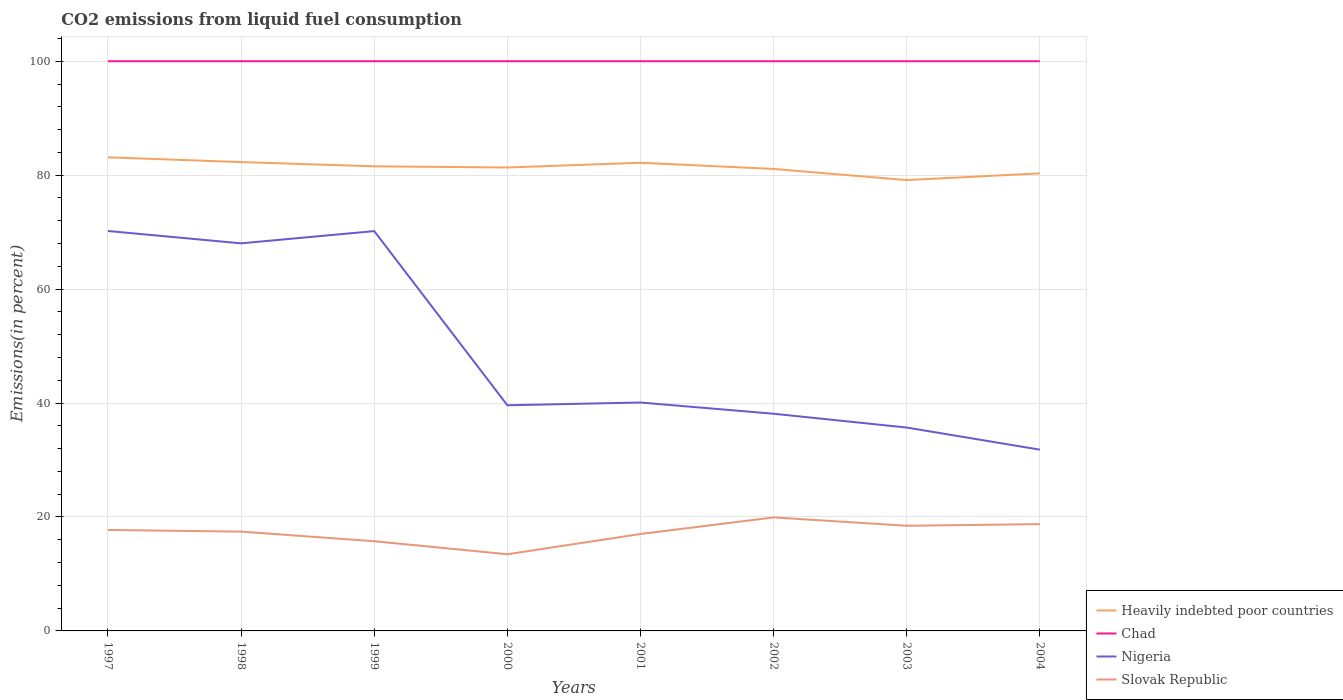How many different coloured lines are there?
Provide a short and direct response. 4. Across all years, what is the maximum total CO2 emitted in Nigeria?
Your answer should be very brief. 31.82. In which year was the total CO2 emitted in Nigeria maximum?
Ensure brevity in your answer.  2004. What is the total total CO2 emitted in Nigeria in the graph?
Make the answer very short. 7.79. What is the difference between the highest and the second highest total CO2 emitted in Heavily indebted poor countries?
Keep it short and to the point. 4. How many years are there in the graph?
Make the answer very short. 8. What is the difference between two consecutive major ticks on the Y-axis?
Provide a succinct answer. 20. Does the graph contain any zero values?
Make the answer very short. No. How many legend labels are there?
Provide a succinct answer. 4. What is the title of the graph?
Your response must be concise. CO2 emissions from liquid fuel consumption. Does "Cayman Islands" appear as one of the legend labels in the graph?
Your answer should be compact. No. What is the label or title of the X-axis?
Offer a very short reply. Years. What is the label or title of the Y-axis?
Ensure brevity in your answer.  Emissions(in percent). What is the Emissions(in percent) of Heavily indebted poor countries in 1997?
Make the answer very short. 83.13. What is the Emissions(in percent) in Nigeria in 1997?
Your answer should be very brief. 70.2. What is the Emissions(in percent) in Slovak Republic in 1997?
Ensure brevity in your answer.  17.72. What is the Emissions(in percent) of Heavily indebted poor countries in 1998?
Your answer should be very brief. 82.3. What is the Emissions(in percent) of Chad in 1998?
Provide a short and direct response. 100. What is the Emissions(in percent) in Nigeria in 1998?
Make the answer very short. 68.03. What is the Emissions(in percent) of Slovak Republic in 1998?
Provide a short and direct response. 17.43. What is the Emissions(in percent) of Heavily indebted poor countries in 1999?
Offer a terse response. 81.55. What is the Emissions(in percent) in Nigeria in 1999?
Provide a succinct answer. 70.18. What is the Emissions(in percent) in Slovak Republic in 1999?
Ensure brevity in your answer.  15.75. What is the Emissions(in percent) in Heavily indebted poor countries in 2000?
Your response must be concise. 81.35. What is the Emissions(in percent) of Nigeria in 2000?
Offer a very short reply. 39.61. What is the Emissions(in percent) of Slovak Republic in 2000?
Your answer should be compact. 13.46. What is the Emissions(in percent) of Heavily indebted poor countries in 2001?
Provide a succinct answer. 82.18. What is the Emissions(in percent) of Nigeria in 2001?
Your response must be concise. 40.09. What is the Emissions(in percent) in Slovak Republic in 2001?
Offer a terse response. 17.01. What is the Emissions(in percent) of Heavily indebted poor countries in 2002?
Keep it short and to the point. 81.09. What is the Emissions(in percent) in Chad in 2002?
Offer a very short reply. 100. What is the Emissions(in percent) in Nigeria in 2002?
Keep it short and to the point. 38.12. What is the Emissions(in percent) of Slovak Republic in 2002?
Offer a terse response. 19.93. What is the Emissions(in percent) of Heavily indebted poor countries in 2003?
Provide a short and direct response. 79.14. What is the Emissions(in percent) in Chad in 2003?
Your answer should be very brief. 100. What is the Emissions(in percent) of Nigeria in 2003?
Keep it short and to the point. 35.7. What is the Emissions(in percent) of Slovak Republic in 2003?
Give a very brief answer. 18.46. What is the Emissions(in percent) of Heavily indebted poor countries in 2004?
Keep it short and to the point. 80.32. What is the Emissions(in percent) of Nigeria in 2004?
Your answer should be compact. 31.82. What is the Emissions(in percent) of Slovak Republic in 2004?
Your answer should be very brief. 18.75. Across all years, what is the maximum Emissions(in percent) in Heavily indebted poor countries?
Your response must be concise. 83.13. Across all years, what is the maximum Emissions(in percent) in Chad?
Keep it short and to the point. 100. Across all years, what is the maximum Emissions(in percent) in Nigeria?
Provide a succinct answer. 70.2. Across all years, what is the maximum Emissions(in percent) of Slovak Republic?
Your response must be concise. 19.93. Across all years, what is the minimum Emissions(in percent) in Heavily indebted poor countries?
Give a very brief answer. 79.14. Across all years, what is the minimum Emissions(in percent) of Nigeria?
Your answer should be compact. 31.82. Across all years, what is the minimum Emissions(in percent) of Slovak Republic?
Offer a terse response. 13.46. What is the total Emissions(in percent) of Heavily indebted poor countries in the graph?
Ensure brevity in your answer.  651.05. What is the total Emissions(in percent) in Chad in the graph?
Provide a short and direct response. 800. What is the total Emissions(in percent) in Nigeria in the graph?
Give a very brief answer. 393.75. What is the total Emissions(in percent) in Slovak Republic in the graph?
Your answer should be very brief. 138.5. What is the difference between the Emissions(in percent) in Heavily indebted poor countries in 1997 and that in 1998?
Your answer should be very brief. 0.84. What is the difference between the Emissions(in percent) of Nigeria in 1997 and that in 1998?
Offer a very short reply. 2.17. What is the difference between the Emissions(in percent) of Slovak Republic in 1997 and that in 1998?
Provide a short and direct response. 0.29. What is the difference between the Emissions(in percent) of Heavily indebted poor countries in 1997 and that in 1999?
Offer a terse response. 1.58. What is the difference between the Emissions(in percent) in Chad in 1997 and that in 1999?
Provide a succinct answer. 0. What is the difference between the Emissions(in percent) of Nigeria in 1997 and that in 1999?
Provide a short and direct response. 0.02. What is the difference between the Emissions(in percent) in Slovak Republic in 1997 and that in 1999?
Provide a short and direct response. 1.98. What is the difference between the Emissions(in percent) in Heavily indebted poor countries in 1997 and that in 2000?
Provide a short and direct response. 1.79. What is the difference between the Emissions(in percent) of Nigeria in 1997 and that in 2000?
Make the answer very short. 30.59. What is the difference between the Emissions(in percent) of Slovak Republic in 1997 and that in 2000?
Make the answer very short. 4.27. What is the difference between the Emissions(in percent) in Heavily indebted poor countries in 1997 and that in 2001?
Provide a succinct answer. 0.96. What is the difference between the Emissions(in percent) of Chad in 1997 and that in 2001?
Offer a very short reply. 0. What is the difference between the Emissions(in percent) of Nigeria in 1997 and that in 2001?
Offer a very short reply. 30.11. What is the difference between the Emissions(in percent) in Slovak Republic in 1997 and that in 2001?
Your answer should be very brief. 0.71. What is the difference between the Emissions(in percent) in Heavily indebted poor countries in 1997 and that in 2002?
Provide a succinct answer. 2.04. What is the difference between the Emissions(in percent) in Chad in 1997 and that in 2002?
Ensure brevity in your answer.  0. What is the difference between the Emissions(in percent) in Nigeria in 1997 and that in 2002?
Give a very brief answer. 32.08. What is the difference between the Emissions(in percent) in Slovak Republic in 1997 and that in 2002?
Your response must be concise. -2.2. What is the difference between the Emissions(in percent) of Heavily indebted poor countries in 1997 and that in 2003?
Provide a succinct answer. 4. What is the difference between the Emissions(in percent) in Chad in 1997 and that in 2003?
Your answer should be compact. 0. What is the difference between the Emissions(in percent) in Nigeria in 1997 and that in 2003?
Your answer should be very brief. 34.5. What is the difference between the Emissions(in percent) of Slovak Republic in 1997 and that in 2003?
Offer a very short reply. -0.73. What is the difference between the Emissions(in percent) in Heavily indebted poor countries in 1997 and that in 2004?
Offer a very short reply. 2.82. What is the difference between the Emissions(in percent) of Nigeria in 1997 and that in 2004?
Your answer should be very brief. 38.39. What is the difference between the Emissions(in percent) of Slovak Republic in 1997 and that in 2004?
Ensure brevity in your answer.  -1.02. What is the difference between the Emissions(in percent) of Heavily indebted poor countries in 1998 and that in 1999?
Give a very brief answer. 0.74. What is the difference between the Emissions(in percent) in Chad in 1998 and that in 1999?
Make the answer very short. 0. What is the difference between the Emissions(in percent) of Nigeria in 1998 and that in 1999?
Your response must be concise. -2.15. What is the difference between the Emissions(in percent) of Slovak Republic in 1998 and that in 1999?
Your answer should be very brief. 1.68. What is the difference between the Emissions(in percent) of Heavily indebted poor countries in 1998 and that in 2000?
Your answer should be compact. 0.95. What is the difference between the Emissions(in percent) in Nigeria in 1998 and that in 2000?
Provide a short and direct response. 28.42. What is the difference between the Emissions(in percent) of Slovak Republic in 1998 and that in 2000?
Give a very brief answer. 3.97. What is the difference between the Emissions(in percent) of Heavily indebted poor countries in 1998 and that in 2001?
Ensure brevity in your answer.  0.12. What is the difference between the Emissions(in percent) of Nigeria in 1998 and that in 2001?
Your response must be concise. 27.94. What is the difference between the Emissions(in percent) in Slovak Republic in 1998 and that in 2001?
Provide a succinct answer. 0.42. What is the difference between the Emissions(in percent) in Heavily indebted poor countries in 1998 and that in 2002?
Provide a succinct answer. 1.2. What is the difference between the Emissions(in percent) in Nigeria in 1998 and that in 2002?
Your response must be concise. 29.91. What is the difference between the Emissions(in percent) of Slovak Republic in 1998 and that in 2002?
Ensure brevity in your answer.  -2.5. What is the difference between the Emissions(in percent) in Heavily indebted poor countries in 1998 and that in 2003?
Keep it short and to the point. 3.16. What is the difference between the Emissions(in percent) in Chad in 1998 and that in 2003?
Offer a terse response. 0. What is the difference between the Emissions(in percent) in Nigeria in 1998 and that in 2003?
Keep it short and to the point. 32.33. What is the difference between the Emissions(in percent) in Slovak Republic in 1998 and that in 2003?
Provide a succinct answer. -1.03. What is the difference between the Emissions(in percent) of Heavily indebted poor countries in 1998 and that in 2004?
Your answer should be compact. 1.98. What is the difference between the Emissions(in percent) in Chad in 1998 and that in 2004?
Offer a terse response. 0. What is the difference between the Emissions(in percent) of Nigeria in 1998 and that in 2004?
Your answer should be compact. 36.22. What is the difference between the Emissions(in percent) of Slovak Republic in 1998 and that in 2004?
Your answer should be very brief. -1.32. What is the difference between the Emissions(in percent) in Heavily indebted poor countries in 1999 and that in 2000?
Keep it short and to the point. 0.21. What is the difference between the Emissions(in percent) of Chad in 1999 and that in 2000?
Provide a succinct answer. 0. What is the difference between the Emissions(in percent) of Nigeria in 1999 and that in 2000?
Offer a terse response. 30.57. What is the difference between the Emissions(in percent) in Slovak Republic in 1999 and that in 2000?
Your answer should be compact. 2.29. What is the difference between the Emissions(in percent) of Heavily indebted poor countries in 1999 and that in 2001?
Your answer should be compact. -0.62. What is the difference between the Emissions(in percent) of Nigeria in 1999 and that in 2001?
Make the answer very short. 30.09. What is the difference between the Emissions(in percent) in Slovak Republic in 1999 and that in 2001?
Offer a very short reply. -1.27. What is the difference between the Emissions(in percent) of Heavily indebted poor countries in 1999 and that in 2002?
Ensure brevity in your answer.  0.46. What is the difference between the Emissions(in percent) in Nigeria in 1999 and that in 2002?
Provide a short and direct response. 32.06. What is the difference between the Emissions(in percent) of Slovak Republic in 1999 and that in 2002?
Keep it short and to the point. -4.18. What is the difference between the Emissions(in percent) in Heavily indebted poor countries in 1999 and that in 2003?
Your response must be concise. 2.42. What is the difference between the Emissions(in percent) in Nigeria in 1999 and that in 2003?
Offer a terse response. 34.48. What is the difference between the Emissions(in percent) of Slovak Republic in 1999 and that in 2003?
Ensure brevity in your answer.  -2.71. What is the difference between the Emissions(in percent) in Heavily indebted poor countries in 1999 and that in 2004?
Provide a succinct answer. 1.24. What is the difference between the Emissions(in percent) of Chad in 1999 and that in 2004?
Offer a terse response. 0. What is the difference between the Emissions(in percent) in Nigeria in 1999 and that in 2004?
Offer a very short reply. 38.37. What is the difference between the Emissions(in percent) of Slovak Republic in 1999 and that in 2004?
Offer a very short reply. -3. What is the difference between the Emissions(in percent) in Heavily indebted poor countries in 2000 and that in 2001?
Ensure brevity in your answer.  -0.83. What is the difference between the Emissions(in percent) in Nigeria in 2000 and that in 2001?
Offer a terse response. -0.48. What is the difference between the Emissions(in percent) in Slovak Republic in 2000 and that in 2001?
Keep it short and to the point. -3.55. What is the difference between the Emissions(in percent) of Heavily indebted poor countries in 2000 and that in 2002?
Your answer should be compact. 0.25. What is the difference between the Emissions(in percent) in Nigeria in 2000 and that in 2002?
Provide a short and direct response. 1.49. What is the difference between the Emissions(in percent) in Slovak Republic in 2000 and that in 2002?
Your response must be concise. -6.47. What is the difference between the Emissions(in percent) of Heavily indebted poor countries in 2000 and that in 2003?
Offer a terse response. 2.21. What is the difference between the Emissions(in percent) in Chad in 2000 and that in 2003?
Provide a short and direct response. 0. What is the difference between the Emissions(in percent) in Nigeria in 2000 and that in 2003?
Provide a succinct answer. 3.91. What is the difference between the Emissions(in percent) in Slovak Republic in 2000 and that in 2003?
Your answer should be compact. -5. What is the difference between the Emissions(in percent) in Heavily indebted poor countries in 2000 and that in 2004?
Ensure brevity in your answer.  1.03. What is the difference between the Emissions(in percent) in Chad in 2000 and that in 2004?
Give a very brief answer. 0. What is the difference between the Emissions(in percent) of Nigeria in 2000 and that in 2004?
Your answer should be compact. 7.79. What is the difference between the Emissions(in percent) in Slovak Republic in 2000 and that in 2004?
Make the answer very short. -5.29. What is the difference between the Emissions(in percent) in Heavily indebted poor countries in 2001 and that in 2002?
Ensure brevity in your answer.  1.08. What is the difference between the Emissions(in percent) of Chad in 2001 and that in 2002?
Your answer should be compact. 0. What is the difference between the Emissions(in percent) of Nigeria in 2001 and that in 2002?
Keep it short and to the point. 1.97. What is the difference between the Emissions(in percent) of Slovak Republic in 2001 and that in 2002?
Your response must be concise. -2.91. What is the difference between the Emissions(in percent) of Heavily indebted poor countries in 2001 and that in 2003?
Give a very brief answer. 3.04. What is the difference between the Emissions(in percent) of Nigeria in 2001 and that in 2003?
Provide a succinct answer. 4.39. What is the difference between the Emissions(in percent) in Slovak Republic in 2001 and that in 2003?
Offer a very short reply. -1.45. What is the difference between the Emissions(in percent) in Heavily indebted poor countries in 2001 and that in 2004?
Your answer should be very brief. 1.86. What is the difference between the Emissions(in percent) in Chad in 2001 and that in 2004?
Your response must be concise. 0. What is the difference between the Emissions(in percent) in Nigeria in 2001 and that in 2004?
Your answer should be very brief. 8.28. What is the difference between the Emissions(in percent) in Slovak Republic in 2001 and that in 2004?
Your answer should be compact. -1.73. What is the difference between the Emissions(in percent) in Heavily indebted poor countries in 2002 and that in 2003?
Make the answer very short. 1.96. What is the difference between the Emissions(in percent) in Nigeria in 2002 and that in 2003?
Give a very brief answer. 2.42. What is the difference between the Emissions(in percent) in Slovak Republic in 2002 and that in 2003?
Your response must be concise. 1.47. What is the difference between the Emissions(in percent) of Heavily indebted poor countries in 2002 and that in 2004?
Provide a succinct answer. 0.78. What is the difference between the Emissions(in percent) in Chad in 2002 and that in 2004?
Offer a very short reply. 0. What is the difference between the Emissions(in percent) in Nigeria in 2002 and that in 2004?
Your answer should be compact. 6.31. What is the difference between the Emissions(in percent) in Slovak Republic in 2002 and that in 2004?
Give a very brief answer. 1.18. What is the difference between the Emissions(in percent) of Heavily indebted poor countries in 2003 and that in 2004?
Give a very brief answer. -1.18. What is the difference between the Emissions(in percent) in Nigeria in 2003 and that in 2004?
Provide a short and direct response. 3.88. What is the difference between the Emissions(in percent) of Slovak Republic in 2003 and that in 2004?
Your answer should be compact. -0.29. What is the difference between the Emissions(in percent) of Heavily indebted poor countries in 1997 and the Emissions(in percent) of Chad in 1998?
Your response must be concise. -16.87. What is the difference between the Emissions(in percent) in Heavily indebted poor countries in 1997 and the Emissions(in percent) in Nigeria in 1998?
Your answer should be very brief. 15.1. What is the difference between the Emissions(in percent) of Heavily indebted poor countries in 1997 and the Emissions(in percent) of Slovak Republic in 1998?
Ensure brevity in your answer.  65.7. What is the difference between the Emissions(in percent) of Chad in 1997 and the Emissions(in percent) of Nigeria in 1998?
Your answer should be very brief. 31.97. What is the difference between the Emissions(in percent) in Chad in 1997 and the Emissions(in percent) in Slovak Republic in 1998?
Ensure brevity in your answer.  82.57. What is the difference between the Emissions(in percent) in Nigeria in 1997 and the Emissions(in percent) in Slovak Republic in 1998?
Offer a very short reply. 52.77. What is the difference between the Emissions(in percent) in Heavily indebted poor countries in 1997 and the Emissions(in percent) in Chad in 1999?
Offer a very short reply. -16.87. What is the difference between the Emissions(in percent) in Heavily indebted poor countries in 1997 and the Emissions(in percent) in Nigeria in 1999?
Provide a succinct answer. 12.95. What is the difference between the Emissions(in percent) in Heavily indebted poor countries in 1997 and the Emissions(in percent) in Slovak Republic in 1999?
Offer a very short reply. 67.39. What is the difference between the Emissions(in percent) in Chad in 1997 and the Emissions(in percent) in Nigeria in 1999?
Your answer should be very brief. 29.82. What is the difference between the Emissions(in percent) in Chad in 1997 and the Emissions(in percent) in Slovak Republic in 1999?
Your answer should be compact. 84.25. What is the difference between the Emissions(in percent) of Nigeria in 1997 and the Emissions(in percent) of Slovak Republic in 1999?
Provide a succinct answer. 54.45. What is the difference between the Emissions(in percent) in Heavily indebted poor countries in 1997 and the Emissions(in percent) in Chad in 2000?
Your answer should be compact. -16.87. What is the difference between the Emissions(in percent) of Heavily indebted poor countries in 1997 and the Emissions(in percent) of Nigeria in 2000?
Make the answer very short. 43.52. What is the difference between the Emissions(in percent) of Heavily indebted poor countries in 1997 and the Emissions(in percent) of Slovak Republic in 2000?
Your answer should be compact. 69.67. What is the difference between the Emissions(in percent) of Chad in 1997 and the Emissions(in percent) of Nigeria in 2000?
Provide a short and direct response. 60.39. What is the difference between the Emissions(in percent) in Chad in 1997 and the Emissions(in percent) in Slovak Republic in 2000?
Offer a very short reply. 86.54. What is the difference between the Emissions(in percent) of Nigeria in 1997 and the Emissions(in percent) of Slovak Republic in 2000?
Offer a terse response. 56.74. What is the difference between the Emissions(in percent) of Heavily indebted poor countries in 1997 and the Emissions(in percent) of Chad in 2001?
Provide a short and direct response. -16.87. What is the difference between the Emissions(in percent) in Heavily indebted poor countries in 1997 and the Emissions(in percent) in Nigeria in 2001?
Offer a very short reply. 43.04. What is the difference between the Emissions(in percent) of Heavily indebted poor countries in 1997 and the Emissions(in percent) of Slovak Republic in 2001?
Your response must be concise. 66.12. What is the difference between the Emissions(in percent) in Chad in 1997 and the Emissions(in percent) in Nigeria in 2001?
Provide a succinct answer. 59.91. What is the difference between the Emissions(in percent) of Chad in 1997 and the Emissions(in percent) of Slovak Republic in 2001?
Your response must be concise. 82.99. What is the difference between the Emissions(in percent) in Nigeria in 1997 and the Emissions(in percent) in Slovak Republic in 2001?
Offer a very short reply. 53.19. What is the difference between the Emissions(in percent) of Heavily indebted poor countries in 1997 and the Emissions(in percent) of Chad in 2002?
Give a very brief answer. -16.87. What is the difference between the Emissions(in percent) of Heavily indebted poor countries in 1997 and the Emissions(in percent) of Nigeria in 2002?
Ensure brevity in your answer.  45.01. What is the difference between the Emissions(in percent) of Heavily indebted poor countries in 1997 and the Emissions(in percent) of Slovak Republic in 2002?
Give a very brief answer. 63.21. What is the difference between the Emissions(in percent) in Chad in 1997 and the Emissions(in percent) in Nigeria in 2002?
Your response must be concise. 61.88. What is the difference between the Emissions(in percent) in Chad in 1997 and the Emissions(in percent) in Slovak Republic in 2002?
Ensure brevity in your answer.  80.07. What is the difference between the Emissions(in percent) in Nigeria in 1997 and the Emissions(in percent) in Slovak Republic in 2002?
Your answer should be compact. 50.27. What is the difference between the Emissions(in percent) in Heavily indebted poor countries in 1997 and the Emissions(in percent) in Chad in 2003?
Ensure brevity in your answer.  -16.87. What is the difference between the Emissions(in percent) of Heavily indebted poor countries in 1997 and the Emissions(in percent) of Nigeria in 2003?
Offer a terse response. 47.43. What is the difference between the Emissions(in percent) of Heavily indebted poor countries in 1997 and the Emissions(in percent) of Slovak Republic in 2003?
Your answer should be very brief. 64.67. What is the difference between the Emissions(in percent) in Chad in 1997 and the Emissions(in percent) in Nigeria in 2003?
Keep it short and to the point. 64.3. What is the difference between the Emissions(in percent) of Chad in 1997 and the Emissions(in percent) of Slovak Republic in 2003?
Make the answer very short. 81.54. What is the difference between the Emissions(in percent) in Nigeria in 1997 and the Emissions(in percent) in Slovak Republic in 2003?
Give a very brief answer. 51.74. What is the difference between the Emissions(in percent) in Heavily indebted poor countries in 1997 and the Emissions(in percent) in Chad in 2004?
Offer a terse response. -16.87. What is the difference between the Emissions(in percent) of Heavily indebted poor countries in 1997 and the Emissions(in percent) of Nigeria in 2004?
Give a very brief answer. 51.32. What is the difference between the Emissions(in percent) of Heavily indebted poor countries in 1997 and the Emissions(in percent) of Slovak Republic in 2004?
Your answer should be very brief. 64.39. What is the difference between the Emissions(in percent) in Chad in 1997 and the Emissions(in percent) in Nigeria in 2004?
Offer a very short reply. 68.18. What is the difference between the Emissions(in percent) in Chad in 1997 and the Emissions(in percent) in Slovak Republic in 2004?
Ensure brevity in your answer.  81.25. What is the difference between the Emissions(in percent) of Nigeria in 1997 and the Emissions(in percent) of Slovak Republic in 2004?
Give a very brief answer. 51.45. What is the difference between the Emissions(in percent) in Heavily indebted poor countries in 1998 and the Emissions(in percent) in Chad in 1999?
Offer a terse response. -17.7. What is the difference between the Emissions(in percent) of Heavily indebted poor countries in 1998 and the Emissions(in percent) of Nigeria in 1999?
Offer a very short reply. 12.11. What is the difference between the Emissions(in percent) of Heavily indebted poor countries in 1998 and the Emissions(in percent) of Slovak Republic in 1999?
Offer a very short reply. 66.55. What is the difference between the Emissions(in percent) of Chad in 1998 and the Emissions(in percent) of Nigeria in 1999?
Make the answer very short. 29.82. What is the difference between the Emissions(in percent) in Chad in 1998 and the Emissions(in percent) in Slovak Republic in 1999?
Your response must be concise. 84.25. What is the difference between the Emissions(in percent) of Nigeria in 1998 and the Emissions(in percent) of Slovak Republic in 1999?
Give a very brief answer. 52.29. What is the difference between the Emissions(in percent) of Heavily indebted poor countries in 1998 and the Emissions(in percent) of Chad in 2000?
Provide a succinct answer. -17.7. What is the difference between the Emissions(in percent) of Heavily indebted poor countries in 1998 and the Emissions(in percent) of Nigeria in 2000?
Keep it short and to the point. 42.69. What is the difference between the Emissions(in percent) of Heavily indebted poor countries in 1998 and the Emissions(in percent) of Slovak Republic in 2000?
Provide a succinct answer. 68.84. What is the difference between the Emissions(in percent) of Chad in 1998 and the Emissions(in percent) of Nigeria in 2000?
Ensure brevity in your answer.  60.39. What is the difference between the Emissions(in percent) in Chad in 1998 and the Emissions(in percent) in Slovak Republic in 2000?
Make the answer very short. 86.54. What is the difference between the Emissions(in percent) of Nigeria in 1998 and the Emissions(in percent) of Slovak Republic in 2000?
Provide a succinct answer. 54.57. What is the difference between the Emissions(in percent) of Heavily indebted poor countries in 1998 and the Emissions(in percent) of Chad in 2001?
Offer a terse response. -17.7. What is the difference between the Emissions(in percent) in Heavily indebted poor countries in 1998 and the Emissions(in percent) in Nigeria in 2001?
Provide a succinct answer. 42.2. What is the difference between the Emissions(in percent) of Heavily indebted poor countries in 1998 and the Emissions(in percent) of Slovak Republic in 2001?
Your answer should be compact. 65.28. What is the difference between the Emissions(in percent) in Chad in 1998 and the Emissions(in percent) in Nigeria in 2001?
Your answer should be very brief. 59.91. What is the difference between the Emissions(in percent) of Chad in 1998 and the Emissions(in percent) of Slovak Republic in 2001?
Provide a short and direct response. 82.99. What is the difference between the Emissions(in percent) of Nigeria in 1998 and the Emissions(in percent) of Slovak Republic in 2001?
Provide a short and direct response. 51.02. What is the difference between the Emissions(in percent) in Heavily indebted poor countries in 1998 and the Emissions(in percent) in Chad in 2002?
Offer a very short reply. -17.7. What is the difference between the Emissions(in percent) of Heavily indebted poor countries in 1998 and the Emissions(in percent) of Nigeria in 2002?
Your answer should be very brief. 44.17. What is the difference between the Emissions(in percent) in Heavily indebted poor countries in 1998 and the Emissions(in percent) in Slovak Republic in 2002?
Keep it short and to the point. 62.37. What is the difference between the Emissions(in percent) in Chad in 1998 and the Emissions(in percent) in Nigeria in 2002?
Offer a terse response. 61.88. What is the difference between the Emissions(in percent) in Chad in 1998 and the Emissions(in percent) in Slovak Republic in 2002?
Give a very brief answer. 80.07. What is the difference between the Emissions(in percent) in Nigeria in 1998 and the Emissions(in percent) in Slovak Republic in 2002?
Provide a succinct answer. 48.11. What is the difference between the Emissions(in percent) in Heavily indebted poor countries in 1998 and the Emissions(in percent) in Chad in 2003?
Keep it short and to the point. -17.7. What is the difference between the Emissions(in percent) of Heavily indebted poor countries in 1998 and the Emissions(in percent) of Nigeria in 2003?
Offer a terse response. 46.6. What is the difference between the Emissions(in percent) in Heavily indebted poor countries in 1998 and the Emissions(in percent) in Slovak Republic in 2003?
Ensure brevity in your answer.  63.84. What is the difference between the Emissions(in percent) in Chad in 1998 and the Emissions(in percent) in Nigeria in 2003?
Make the answer very short. 64.3. What is the difference between the Emissions(in percent) of Chad in 1998 and the Emissions(in percent) of Slovak Republic in 2003?
Your response must be concise. 81.54. What is the difference between the Emissions(in percent) of Nigeria in 1998 and the Emissions(in percent) of Slovak Republic in 2003?
Provide a succinct answer. 49.57. What is the difference between the Emissions(in percent) of Heavily indebted poor countries in 1998 and the Emissions(in percent) of Chad in 2004?
Keep it short and to the point. -17.7. What is the difference between the Emissions(in percent) in Heavily indebted poor countries in 1998 and the Emissions(in percent) in Nigeria in 2004?
Your answer should be very brief. 50.48. What is the difference between the Emissions(in percent) of Heavily indebted poor countries in 1998 and the Emissions(in percent) of Slovak Republic in 2004?
Your response must be concise. 63.55. What is the difference between the Emissions(in percent) in Chad in 1998 and the Emissions(in percent) in Nigeria in 2004?
Your response must be concise. 68.18. What is the difference between the Emissions(in percent) of Chad in 1998 and the Emissions(in percent) of Slovak Republic in 2004?
Make the answer very short. 81.25. What is the difference between the Emissions(in percent) of Nigeria in 1998 and the Emissions(in percent) of Slovak Republic in 2004?
Provide a succinct answer. 49.29. What is the difference between the Emissions(in percent) of Heavily indebted poor countries in 1999 and the Emissions(in percent) of Chad in 2000?
Offer a terse response. -18.45. What is the difference between the Emissions(in percent) of Heavily indebted poor countries in 1999 and the Emissions(in percent) of Nigeria in 2000?
Keep it short and to the point. 41.94. What is the difference between the Emissions(in percent) in Heavily indebted poor countries in 1999 and the Emissions(in percent) in Slovak Republic in 2000?
Make the answer very short. 68.1. What is the difference between the Emissions(in percent) in Chad in 1999 and the Emissions(in percent) in Nigeria in 2000?
Provide a short and direct response. 60.39. What is the difference between the Emissions(in percent) of Chad in 1999 and the Emissions(in percent) of Slovak Republic in 2000?
Ensure brevity in your answer.  86.54. What is the difference between the Emissions(in percent) in Nigeria in 1999 and the Emissions(in percent) in Slovak Republic in 2000?
Ensure brevity in your answer.  56.72. What is the difference between the Emissions(in percent) of Heavily indebted poor countries in 1999 and the Emissions(in percent) of Chad in 2001?
Keep it short and to the point. -18.45. What is the difference between the Emissions(in percent) of Heavily indebted poor countries in 1999 and the Emissions(in percent) of Nigeria in 2001?
Your answer should be compact. 41.46. What is the difference between the Emissions(in percent) of Heavily indebted poor countries in 1999 and the Emissions(in percent) of Slovak Republic in 2001?
Provide a short and direct response. 64.54. What is the difference between the Emissions(in percent) in Chad in 1999 and the Emissions(in percent) in Nigeria in 2001?
Provide a succinct answer. 59.91. What is the difference between the Emissions(in percent) in Chad in 1999 and the Emissions(in percent) in Slovak Republic in 2001?
Your response must be concise. 82.99. What is the difference between the Emissions(in percent) in Nigeria in 1999 and the Emissions(in percent) in Slovak Republic in 2001?
Give a very brief answer. 53.17. What is the difference between the Emissions(in percent) in Heavily indebted poor countries in 1999 and the Emissions(in percent) in Chad in 2002?
Offer a terse response. -18.45. What is the difference between the Emissions(in percent) of Heavily indebted poor countries in 1999 and the Emissions(in percent) of Nigeria in 2002?
Your response must be concise. 43.43. What is the difference between the Emissions(in percent) in Heavily indebted poor countries in 1999 and the Emissions(in percent) in Slovak Republic in 2002?
Your response must be concise. 61.63. What is the difference between the Emissions(in percent) of Chad in 1999 and the Emissions(in percent) of Nigeria in 2002?
Give a very brief answer. 61.88. What is the difference between the Emissions(in percent) of Chad in 1999 and the Emissions(in percent) of Slovak Republic in 2002?
Your response must be concise. 80.07. What is the difference between the Emissions(in percent) in Nigeria in 1999 and the Emissions(in percent) in Slovak Republic in 2002?
Make the answer very short. 50.25. What is the difference between the Emissions(in percent) in Heavily indebted poor countries in 1999 and the Emissions(in percent) in Chad in 2003?
Offer a very short reply. -18.45. What is the difference between the Emissions(in percent) of Heavily indebted poor countries in 1999 and the Emissions(in percent) of Nigeria in 2003?
Your response must be concise. 45.86. What is the difference between the Emissions(in percent) in Heavily indebted poor countries in 1999 and the Emissions(in percent) in Slovak Republic in 2003?
Ensure brevity in your answer.  63.1. What is the difference between the Emissions(in percent) of Chad in 1999 and the Emissions(in percent) of Nigeria in 2003?
Ensure brevity in your answer.  64.3. What is the difference between the Emissions(in percent) of Chad in 1999 and the Emissions(in percent) of Slovak Republic in 2003?
Ensure brevity in your answer.  81.54. What is the difference between the Emissions(in percent) in Nigeria in 1999 and the Emissions(in percent) in Slovak Republic in 2003?
Offer a very short reply. 51.72. What is the difference between the Emissions(in percent) of Heavily indebted poor countries in 1999 and the Emissions(in percent) of Chad in 2004?
Make the answer very short. -18.45. What is the difference between the Emissions(in percent) of Heavily indebted poor countries in 1999 and the Emissions(in percent) of Nigeria in 2004?
Your response must be concise. 49.74. What is the difference between the Emissions(in percent) of Heavily indebted poor countries in 1999 and the Emissions(in percent) of Slovak Republic in 2004?
Keep it short and to the point. 62.81. What is the difference between the Emissions(in percent) in Chad in 1999 and the Emissions(in percent) in Nigeria in 2004?
Provide a short and direct response. 68.18. What is the difference between the Emissions(in percent) in Chad in 1999 and the Emissions(in percent) in Slovak Republic in 2004?
Keep it short and to the point. 81.25. What is the difference between the Emissions(in percent) of Nigeria in 1999 and the Emissions(in percent) of Slovak Republic in 2004?
Provide a short and direct response. 51.43. What is the difference between the Emissions(in percent) of Heavily indebted poor countries in 2000 and the Emissions(in percent) of Chad in 2001?
Your answer should be very brief. -18.65. What is the difference between the Emissions(in percent) in Heavily indebted poor countries in 2000 and the Emissions(in percent) in Nigeria in 2001?
Make the answer very short. 41.25. What is the difference between the Emissions(in percent) of Heavily indebted poor countries in 2000 and the Emissions(in percent) of Slovak Republic in 2001?
Give a very brief answer. 64.33. What is the difference between the Emissions(in percent) in Chad in 2000 and the Emissions(in percent) in Nigeria in 2001?
Offer a terse response. 59.91. What is the difference between the Emissions(in percent) of Chad in 2000 and the Emissions(in percent) of Slovak Republic in 2001?
Make the answer very short. 82.99. What is the difference between the Emissions(in percent) in Nigeria in 2000 and the Emissions(in percent) in Slovak Republic in 2001?
Your answer should be compact. 22.6. What is the difference between the Emissions(in percent) in Heavily indebted poor countries in 2000 and the Emissions(in percent) in Chad in 2002?
Provide a succinct answer. -18.65. What is the difference between the Emissions(in percent) of Heavily indebted poor countries in 2000 and the Emissions(in percent) of Nigeria in 2002?
Provide a succinct answer. 43.22. What is the difference between the Emissions(in percent) in Heavily indebted poor countries in 2000 and the Emissions(in percent) in Slovak Republic in 2002?
Keep it short and to the point. 61.42. What is the difference between the Emissions(in percent) in Chad in 2000 and the Emissions(in percent) in Nigeria in 2002?
Your answer should be compact. 61.88. What is the difference between the Emissions(in percent) in Chad in 2000 and the Emissions(in percent) in Slovak Republic in 2002?
Provide a short and direct response. 80.07. What is the difference between the Emissions(in percent) in Nigeria in 2000 and the Emissions(in percent) in Slovak Republic in 2002?
Provide a short and direct response. 19.68. What is the difference between the Emissions(in percent) of Heavily indebted poor countries in 2000 and the Emissions(in percent) of Chad in 2003?
Give a very brief answer. -18.65. What is the difference between the Emissions(in percent) of Heavily indebted poor countries in 2000 and the Emissions(in percent) of Nigeria in 2003?
Keep it short and to the point. 45.65. What is the difference between the Emissions(in percent) in Heavily indebted poor countries in 2000 and the Emissions(in percent) in Slovak Republic in 2003?
Your response must be concise. 62.89. What is the difference between the Emissions(in percent) in Chad in 2000 and the Emissions(in percent) in Nigeria in 2003?
Provide a succinct answer. 64.3. What is the difference between the Emissions(in percent) in Chad in 2000 and the Emissions(in percent) in Slovak Republic in 2003?
Offer a terse response. 81.54. What is the difference between the Emissions(in percent) in Nigeria in 2000 and the Emissions(in percent) in Slovak Republic in 2003?
Provide a short and direct response. 21.15. What is the difference between the Emissions(in percent) in Heavily indebted poor countries in 2000 and the Emissions(in percent) in Chad in 2004?
Ensure brevity in your answer.  -18.65. What is the difference between the Emissions(in percent) of Heavily indebted poor countries in 2000 and the Emissions(in percent) of Nigeria in 2004?
Your response must be concise. 49.53. What is the difference between the Emissions(in percent) in Heavily indebted poor countries in 2000 and the Emissions(in percent) in Slovak Republic in 2004?
Your answer should be compact. 62.6. What is the difference between the Emissions(in percent) of Chad in 2000 and the Emissions(in percent) of Nigeria in 2004?
Give a very brief answer. 68.18. What is the difference between the Emissions(in percent) in Chad in 2000 and the Emissions(in percent) in Slovak Republic in 2004?
Your answer should be compact. 81.25. What is the difference between the Emissions(in percent) of Nigeria in 2000 and the Emissions(in percent) of Slovak Republic in 2004?
Your answer should be very brief. 20.86. What is the difference between the Emissions(in percent) in Heavily indebted poor countries in 2001 and the Emissions(in percent) in Chad in 2002?
Give a very brief answer. -17.82. What is the difference between the Emissions(in percent) in Heavily indebted poor countries in 2001 and the Emissions(in percent) in Nigeria in 2002?
Your answer should be compact. 44.05. What is the difference between the Emissions(in percent) of Heavily indebted poor countries in 2001 and the Emissions(in percent) of Slovak Republic in 2002?
Ensure brevity in your answer.  62.25. What is the difference between the Emissions(in percent) in Chad in 2001 and the Emissions(in percent) in Nigeria in 2002?
Provide a succinct answer. 61.88. What is the difference between the Emissions(in percent) of Chad in 2001 and the Emissions(in percent) of Slovak Republic in 2002?
Offer a very short reply. 80.07. What is the difference between the Emissions(in percent) in Nigeria in 2001 and the Emissions(in percent) in Slovak Republic in 2002?
Make the answer very short. 20.17. What is the difference between the Emissions(in percent) in Heavily indebted poor countries in 2001 and the Emissions(in percent) in Chad in 2003?
Give a very brief answer. -17.82. What is the difference between the Emissions(in percent) in Heavily indebted poor countries in 2001 and the Emissions(in percent) in Nigeria in 2003?
Make the answer very short. 46.48. What is the difference between the Emissions(in percent) in Heavily indebted poor countries in 2001 and the Emissions(in percent) in Slovak Republic in 2003?
Your answer should be very brief. 63.72. What is the difference between the Emissions(in percent) of Chad in 2001 and the Emissions(in percent) of Nigeria in 2003?
Offer a terse response. 64.3. What is the difference between the Emissions(in percent) of Chad in 2001 and the Emissions(in percent) of Slovak Republic in 2003?
Make the answer very short. 81.54. What is the difference between the Emissions(in percent) in Nigeria in 2001 and the Emissions(in percent) in Slovak Republic in 2003?
Give a very brief answer. 21.63. What is the difference between the Emissions(in percent) of Heavily indebted poor countries in 2001 and the Emissions(in percent) of Chad in 2004?
Offer a very short reply. -17.82. What is the difference between the Emissions(in percent) in Heavily indebted poor countries in 2001 and the Emissions(in percent) in Nigeria in 2004?
Give a very brief answer. 50.36. What is the difference between the Emissions(in percent) in Heavily indebted poor countries in 2001 and the Emissions(in percent) in Slovak Republic in 2004?
Offer a terse response. 63.43. What is the difference between the Emissions(in percent) of Chad in 2001 and the Emissions(in percent) of Nigeria in 2004?
Make the answer very short. 68.18. What is the difference between the Emissions(in percent) in Chad in 2001 and the Emissions(in percent) in Slovak Republic in 2004?
Your answer should be very brief. 81.25. What is the difference between the Emissions(in percent) in Nigeria in 2001 and the Emissions(in percent) in Slovak Republic in 2004?
Provide a succinct answer. 21.35. What is the difference between the Emissions(in percent) of Heavily indebted poor countries in 2002 and the Emissions(in percent) of Chad in 2003?
Ensure brevity in your answer.  -18.91. What is the difference between the Emissions(in percent) in Heavily indebted poor countries in 2002 and the Emissions(in percent) in Nigeria in 2003?
Your answer should be very brief. 45.39. What is the difference between the Emissions(in percent) of Heavily indebted poor countries in 2002 and the Emissions(in percent) of Slovak Republic in 2003?
Make the answer very short. 62.63. What is the difference between the Emissions(in percent) in Chad in 2002 and the Emissions(in percent) in Nigeria in 2003?
Your answer should be very brief. 64.3. What is the difference between the Emissions(in percent) of Chad in 2002 and the Emissions(in percent) of Slovak Republic in 2003?
Your answer should be compact. 81.54. What is the difference between the Emissions(in percent) of Nigeria in 2002 and the Emissions(in percent) of Slovak Republic in 2003?
Give a very brief answer. 19.66. What is the difference between the Emissions(in percent) of Heavily indebted poor countries in 2002 and the Emissions(in percent) of Chad in 2004?
Your answer should be very brief. -18.91. What is the difference between the Emissions(in percent) of Heavily indebted poor countries in 2002 and the Emissions(in percent) of Nigeria in 2004?
Make the answer very short. 49.28. What is the difference between the Emissions(in percent) of Heavily indebted poor countries in 2002 and the Emissions(in percent) of Slovak Republic in 2004?
Make the answer very short. 62.35. What is the difference between the Emissions(in percent) of Chad in 2002 and the Emissions(in percent) of Nigeria in 2004?
Your answer should be compact. 68.18. What is the difference between the Emissions(in percent) in Chad in 2002 and the Emissions(in percent) in Slovak Republic in 2004?
Make the answer very short. 81.25. What is the difference between the Emissions(in percent) in Nigeria in 2002 and the Emissions(in percent) in Slovak Republic in 2004?
Your answer should be compact. 19.37. What is the difference between the Emissions(in percent) in Heavily indebted poor countries in 2003 and the Emissions(in percent) in Chad in 2004?
Your answer should be compact. -20.86. What is the difference between the Emissions(in percent) in Heavily indebted poor countries in 2003 and the Emissions(in percent) in Nigeria in 2004?
Offer a terse response. 47.32. What is the difference between the Emissions(in percent) of Heavily indebted poor countries in 2003 and the Emissions(in percent) of Slovak Republic in 2004?
Your answer should be compact. 60.39. What is the difference between the Emissions(in percent) of Chad in 2003 and the Emissions(in percent) of Nigeria in 2004?
Offer a terse response. 68.18. What is the difference between the Emissions(in percent) of Chad in 2003 and the Emissions(in percent) of Slovak Republic in 2004?
Give a very brief answer. 81.25. What is the difference between the Emissions(in percent) in Nigeria in 2003 and the Emissions(in percent) in Slovak Republic in 2004?
Ensure brevity in your answer.  16.95. What is the average Emissions(in percent) in Heavily indebted poor countries per year?
Keep it short and to the point. 81.38. What is the average Emissions(in percent) in Nigeria per year?
Make the answer very short. 49.22. What is the average Emissions(in percent) of Slovak Republic per year?
Offer a very short reply. 17.31. In the year 1997, what is the difference between the Emissions(in percent) in Heavily indebted poor countries and Emissions(in percent) in Chad?
Offer a terse response. -16.87. In the year 1997, what is the difference between the Emissions(in percent) of Heavily indebted poor countries and Emissions(in percent) of Nigeria?
Your response must be concise. 12.93. In the year 1997, what is the difference between the Emissions(in percent) of Heavily indebted poor countries and Emissions(in percent) of Slovak Republic?
Make the answer very short. 65.41. In the year 1997, what is the difference between the Emissions(in percent) in Chad and Emissions(in percent) in Nigeria?
Your answer should be very brief. 29.8. In the year 1997, what is the difference between the Emissions(in percent) in Chad and Emissions(in percent) in Slovak Republic?
Offer a very short reply. 82.28. In the year 1997, what is the difference between the Emissions(in percent) of Nigeria and Emissions(in percent) of Slovak Republic?
Your answer should be very brief. 52.48. In the year 1998, what is the difference between the Emissions(in percent) in Heavily indebted poor countries and Emissions(in percent) in Chad?
Ensure brevity in your answer.  -17.7. In the year 1998, what is the difference between the Emissions(in percent) of Heavily indebted poor countries and Emissions(in percent) of Nigeria?
Ensure brevity in your answer.  14.26. In the year 1998, what is the difference between the Emissions(in percent) of Heavily indebted poor countries and Emissions(in percent) of Slovak Republic?
Your answer should be very brief. 64.87. In the year 1998, what is the difference between the Emissions(in percent) in Chad and Emissions(in percent) in Nigeria?
Offer a very short reply. 31.97. In the year 1998, what is the difference between the Emissions(in percent) of Chad and Emissions(in percent) of Slovak Republic?
Provide a short and direct response. 82.57. In the year 1998, what is the difference between the Emissions(in percent) in Nigeria and Emissions(in percent) in Slovak Republic?
Offer a terse response. 50.6. In the year 1999, what is the difference between the Emissions(in percent) in Heavily indebted poor countries and Emissions(in percent) in Chad?
Ensure brevity in your answer.  -18.45. In the year 1999, what is the difference between the Emissions(in percent) of Heavily indebted poor countries and Emissions(in percent) of Nigeria?
Offer a terse response. 11.37. In the year 1999, what is the difference between the Emissions(in percent) of Heavily indebted poor countries and Emissions(in percent) of Slovak Republic?
Your response must be concise. 65.81. In the year 1999, what is the difference between the Emissions(in percent) of Chad and Emissions(in percent) of Nigeria?
Offer a terse response. 29.82. In the year 1999, what is the difference between the Emissions(in percent) in Chad and Emissions(in percent) in Slovak Republic?
Offer a very short reply. 84.25. In the year 1999, what is the difference between the Emissions(in percent) in Nigeria and Emissions(in percent) in Slovak Republic?
Ensure brevity in your answer.  54.44. In the year 2000, what is the difference between the Emissions(in percent) in Heavily indebted poor countries and Emissions(in percent) in Chad?
Make the answer very short. -18.65. In the year 2000, what is the difference between the Emissions(in percent) in Heavily indebted poor countries and Emissions(in percent) in Nigeria?
Your answer should be very brief. 41.74. In the year 2000, what is the difference between the Emissions(in percent) in Heavily indebted poor countries and Emissions(in percent) in Slovak Republic?
Ensure brevity in your answer.  67.89. In the year 2000, what is the difference between the Emissions(in percent) in Chad and Emissions(in percent) in Nigeria?
Offer a terse response. 60.39. In the year 2000, what is the difference between the Emissions(in percent) in Chad and Emissions(in percent) in Slovak Republic?
Offer a terse response. 86.54. In the year 2000, what is the difference between the Emissions(in percent) in Nigeria and Emissions(in percent) in Slovak Republic?
Make the answer very short. 26.15. In the year 2001, what is the difference between the Emissions(in percent) in Heavily indebted poor countries and Emissions(in percent) in Chad?
Provide a succinct answer. -17.82. In the year 2001, what is the difference between the Emissions(in percent) in Heavily indebted poor countries and Emissions(in percent) in Nigeria?
Provide a short and direct response. 42.08. In the year 2001, what is the difference between the Emissions(in percent) of Heavily indebted poor countries and Emissions(in percent) of Slovak Republic?
Your answer should be compact. 65.16. In the year 2001, what is the difference between the Emissions(in percent) in Chad and Emissions(in percent) in Nigeria?
Your answer should be very brief. 59.91. In the year 2001, what is the difference between the Emissions(in percent) of Chad and Emissions(in percent) of Slovak Republic?
Offer a very short reply. 82.99. In the year 2001, what is the difference between the Emissions(in percent) of Nigeria and Emissions(in percent) of Slovak Republic?
Your answer should be very brief. 23.08. In the year 2002, what is the difference between the Emissions(in percent) in Heavily indebted poor countries and Emissions(in percent) in Chad?
Your answer should be very brief. -18.91. In the year 2002, what is the difference between the Emissions(in percent) of Heavily indebted poor countries and Emissions(in percent) of Nigeria?
Provide a succinct answer. 42.97. In the year 2002, what is the difference between the Emissions(in percent) of Heavily indebted poor countries and Emissions(in percent) of Slovak Republic?
Give a very brief answer. 61.17. In the year 2002, what is the difference between the Emissions(in percent) in Chad and Emissions(in percent) in Nigeria?
Offer a very short reply. 61.88. In the year 2002, what is the difference between the Emissions(in percent) in Chad and Emissions(in percent) in Slovak Republic?
Your answer should be compact. 80.07. In the year 2002, what is the difference between the Emissions(in percent) of Nigeria and Emissions(in percent) of Slovak Republic?
Provide a short and direct response. 18.19. In the year 2003, what is the difference between the Emissions(in percent) of Heavily indebted poor countries and Emissions(in percent) of Chad?
Provide a short and direct response. -20.86. In the year 2003, what is the difference between the Emissions(in percent) of Heavily indebted poor countries and Emissions(in percent) of Nigeria?
Your answer should be compact. 43.44. In the year 2003, what is the difference between the Emissions(in percent) of Heavily indebted poor countries and Emissions(in percent) of Slovak Republic?
Provide a short and direct response. 60.68. In the year 2003, what is the difference between the Emissions(in percent) in Chad and Emissions(in percent) in Nigeria?
Provide a succinct answer. 64.3. In the year 2003, what is the difference between the Emissions(in percent) in Chad and Emissions(in percent) in Slovak Republic?
Keep it short and to the point. 81.54. In the year 2003, what is the difference between the Emissions(in percent) of Nigeria and Emissions(in percent) of Slovak Republic?
Your response must be concise. 17.24. In the year 2004, what is the difference between the Emissions(in percent) in Heavily indebted poor countries and Emissions(in percent) in Chad?
Offer a very short reply. -19.68. In the year 2004, what is the difference between the Emissions(in percent) in Heavily indebted poor countries and Emissions(in percent) in Nigeria?
Your response must be concise. 48.5. In the year 2004, what is the difference between the Emissions(in percent) in Heavily indebted poor countries and Emissions(in percent) in Slovak Republic?
Make the answer very short. 61.57. In the year 2004, what is the difference between the Emissions(in percent) of Chad and Emissions(in percent) of Nigeria?
Ensure brevity in your answer.  68.18. In the year 2004, what is the difference between the Emissions(in percent) of Chad and Emissions(in percent) of Slovak Republic?
Your answer should be compact. 81.25. In the year 2004, what is the difference between the Emissions(in percent) in Nigeria and Emissions(in percent) in Slovak Republic?
Your response must be concise. 13.07. What is the ratio of the Emissions(in percent) of Heavily indebted poor countries in 1997 to that in 1998?
Your response must be concise. 1.01. What is the ratio of the Emissions(in percent) of Nigeria in 1997 to that in 1998?
Make the answer very short. 1.03. What is the ratio of the Emissions(in percent) of Slovak Republic in 1997 to that in 1998?
Offer a very short reply. 1.02. What is the ratio of the Emissions(in percent) of Heavily indebted poor countries in 1997 to that in 1999?
Your response must be concise. 1.02. What is the ratio of the Emissions(in percent) in Chad in 1997 to that in 1999?
Your response must be concise. 1. What is the ratio of the Emissions(in percent) in Slovak Republic in 1997 to that in 1999?
Keep it short and to the point. 1.13. What is the ratio of the Emissions(in percent) in Nigeria in 1997 to that in 2000?
Give a very brief answer. 1.77. What is the ratio of the Emissions(in percent) of Slovak Republic in 1997 to that in 2000?
Your response must be concise. 1.32. What is the ratio of the Emissions(in percent) of Heavily indebted poor countries in 1997 to that in 2001?
Your answer should be very brief. 1.01. What is the ratio of the Emissions(in percent) of Chad in 1997 to that in 2001?
Your response must be concise. 1. What is the ratio of the Emissions(in percent) in Nigeria in 1997 to that in 2001?
Provide a succinct answer. 1.75. What is the ratio of the Emissions(in percent) of Slovak Republic in 1997 to that in 2001?
Make the answer very short. 1.04. What is the ratio of the Emissions(in percent) in Heavily indebted poor countries in 1997 to that in 2002?
Offer a very short reply. 1.03. What is the ratio of the Emissions(in percent) of Chad in 1997 to that in 2002?
Provide a succinct answer. 1. What is the ratio of the Emissions(in percent) of Nigeria in 1997 to that in 2002?
Provide a succinct answer. 1.84. What is the ratio of the Emissions(in percent) of Slovak Republic in 1997 to that in 2002?
Your response must be concise. 0.89. What is the ratio of the Emissions(in percent) in Heavily indebted poor countries in 1997 to that in 2003?
Give a very brief answer. 1.05. What is the ratio of the Emissions(in percent) of Nigeria in 1997 to that in 2003?
Make the answer very short. 1.97. What is the ratio of the Emissions(in percent) in Slovak Republic in 1997 to that in 2003?
Offer a terse response. 0.96. What is the ratio of the Emissions(in percent) in Heavily indebted poor countries in 1997 to that in 2004?
Offer a terse response. 1.04. What is the ratio of the Emissions(in percent) of Chad in 1997 to that in 2004?
Offer a very short reply. 1. What is the ratio of the Emissions(in percent) in Nigeria in 1997 to that in 2004?
Give a very brief answer. 2.21. What is the ratio of the Emissions(in percent) of Slovak Republic in 1997 to that in 2004?
Ensure brevity in your answer.  0.95. What is the ratio of the Emissions(in percent) of Heavily indebted poor countries in 1998 to that in 1999?
Provide a succinct answer. 1.01. What is the ratio of the Emissions(in percent) in Chad in 1998 to that in 1999?
Offer a very short reply. 1. What is the ratio of the Emissions(in percent) of Nigeria in 1998 to that in 1999?
Ensure brevity in your answer.  0.97. What is the ratio of the Emissions(in percent) in Slovak Republic in 1998 to that in 1999?
Your response must be concise. 1.11. What is the ratio of the Emissions(in percent) in Heavily indebted poor countries in 1998 to that in 2000?
Offer a terse response. 1.01. What is the ratio of the Emissions(in percent) in Chad in 1998 to that in 2000?
Your response must be concise. 1. What is the ratio of the Emissions(in percent) of Nigeria in 1998 to that in 2000?
Give a very brief answer. 1.72. What is the ratio of the Emissions(in percent) of Slovak Republic in 1998 to that in 2000?
Offer a terse response. 1.3. What is the ratio of the Emissions(in percent) in Heavily indebted poor countries in 1998 to that in 2001?
Your response must be concise. 1. What is the ratio of the Emissions(in percent) of Chad in 1998 to that in 2001?
Your answer should be compact. 1. What is the ratio of the Emissions(in percent) of Nigeria in 1998 to that in 2001?
Keep it short and to the point. 1.7. What is the ratio of the Emissions(in percent) of Slovak Republic in 1998 to that in 2001?
Provide a short and direct response. 1.02. What is the ratio of the Emissions(in percent) in Heavily indebted poor countries in 1998 to that in 2002?
Provide a short and direct response. 1.01. What is the ratio of the Emissions(in percent) in Chad in 1998 to that in 2002?
Keep it short and to the point. 1. What is the ratio of the Emissions(in percent) in Nigeria in 1998 to that in 2002?
Give a very brief answer. 1.78. What is the ratio of the Emissions(in percent) in Slovak Republic in 1998 to that in 2002?
Make the answer very short. 0.87. What is the ratio of the Emissions(in percent) in Heavily indebted poor countries in 1998 to that in 2003?
Keep it short and to the point. 1.04. What is the ratio of the Emissions(in percent) of Nigeria in 1998 to that in 2003?
Ensure brevity in your answer.  1.91. What is the ratio of the Emissions(in percent) in Slovak Republic in 1998 to that in 2003?
Ensure brevity in your answer.  0.94. What is the ratio of the Emissions(in percent) of Heavily indebted poor countries in 1998 to that in 2004?
Offer a very short reply. 1.02. What is the ratio of the Emissions(in percent) of Chad in 1998 to that in 2004?
Your answer should be compact. 1. What is the ratio of the Emissions(in percent) in Nigeria in 1998 to that in 2004?
Your response must be concise. 2.14. What is the ratio of the Emissions(in percent) of Slovak Republic in 1998 to that in 2004?
Give a very brief answer. 0.93. What is the ratio of the Emissions(in percent) in Heavily indebted poor countries in 1999 to that in 2000?
Provide a short and direct response. 1. What is the ratio of the Emissions(in percent) in Nigeria in 1999 to that in 2000?
Offer a terse response. 1.77. What is the ratio of the Emissions(in percent) in Slovak Republic in 1999 to that in 2000?
Offer a very short reply. 1.17. What is the ratio of the Emissions(in percent) in Chad in 1999 to that in 2001?
Provide a short and direct response. 1. What is the ratio of the Emissions(in percent) of Nigeria in 1999 to that in 2001?
Keep it short and to the point. 1.75. What is the ratio of the Emissions(in percent) in Slovak Republic in 1999 to that in 2001?
Provide a short and direct response. 0.93. What is the ratio of the Emissions(in percent) of Heavily indebted poor countries in 1999 to that in 2002?
Offer a terse response. 1.01. What is the ratio of the Emissions(in percent) of Chad in 1999 to that in 2002?
Make the answer very short. 1. What is the ratio of the Emissions(in percent) in Nigeria in 1999 to that in 2002?
Make the answer very short. 1.84. What is the ratio of the Emissions(in percent) in Slovak Republic in 1999 to that in 2002?
Your answer should be very brief. 0.79. What is the ratio of the Emissions(in percent) of Heavily indebted poor countries in 1999 to that in 2003?
Your response must be concise. 1.03. What is the ratio of the Emissions(in percent) of Nigeria in 1999 to that in 2003?
Your answer should be very brief. 1.97. What is the ratio of the Emissions(in percent) in Slovak Republic in 1999 to that in 2003?
Ensure brevity in your answer.  0.85. What is the ratio of the Emissions(in percent) in Heavily indebted poor countries in 1999 to that in 2004?
Provide a succinct answer. 1.02. What is the ratio of the Emissions(in percent) of Nigeria in 1999 to that in 2004?
Ensure brevity in your answer.  2.21. What is the ratio of the Emissions(in percent) of Slovak Republic in 1999 to that in 2004?
Give a very brief answer. 0.84. What is the ratio of the Emissions(in percent) in Slovak Republic in 2000 to that in 2001?
Provide a succinct answer. 0.79. What is the ratio of the Emissions(in percent) in Nigeria in 2000 to that in 2002?
Offer a very short reply. 1.04. What is the ratio of the Emissions(in percent) of Slovak Republic in 2000 to that in 2002?
Provide a succinct answer. 0.68. What is the ratio of the Emissions(in percent) in Heavily indebted poor countries in 2000 to that in 2003?
Your answer should be very brief. 1.03. What is the ratio of the Emissions(in percent) in Chad in 2000 to that in 2003?
Provide a succinct answer. 1. What is the ratio of the Emissions(in percent) in Nigeria in 2000 to that in 2003?
Offer a very short reply. 1.11. What is the ratio of the Emissions(in percent) in Slovak Republic in 2000 to that in 2003?
Offer a terse response. 0.73. What is the ratio of the Emissions(in percent) of Heavily indebted poor countries in 2000 to that in 2004?
Ensure brevity in your answer.  1.01. What is the ratio of the Emissions(in percent) in Chad in 2000 to that in 2004?
Your answer should be compact. 1. What is the ratio of the Emissions(in percent) in Nigeria in 2000 to that in 2004?
Ensure brevity in your answer.  1.25. What is the ratio of the Emissions(in percent) in Slovak Republic in 2000 to that in 2004?
Offer a very short reply. 0.72. What is the ratio of the Emissions(in percent) in Heavily indebted poor countries in 2001 to that in 2002?
Ensure brevity in your answer.  1.01. What is the ratio of the Emissions(in percent) of Chad in 2001 to that in 2002?
Offer a terse response. 1. What is the ratio of the Emissions(in percent) of Nigeria in 2001 to that in 2002?
Offer a terse response. 1.05. What is the ratio of the Emissions(in percent) in Slovak Republic in 2001 to that in 2002?
Offer a terse response. 0.85. What is the ratio of the Emissions(in percent) of Heavily indebted poor countries in 2001 to that in 2003?
Ensure brevity in your answer.  1.04. What is the ratio of the Emissions(in percent) in Chad in 2001 to that in 2003?
Your answer should be very brief. 1. What is the ratio of the Emissions(in percent) in Nigeria in 2001 to that in 2003?
Provide a short and direct response. 1.12. What is the ratio of the Emissions(in percent) in Slovak Republic in 2001 to that in 2003?
Make the answer very short. 0.92. What is the ratio of the Emissions(in percent) of Heavily indebted poor countries in 2001 to that in 2004?
Ensure brevity in your answer.  1.02. What is the ratio of the Emissions(in percent) in Chad in 2001 to that in 2004?
Provide a succinct answer. 1. What is the ratio of the Emissions(in percent) of Nigeria in 2001 to that in 2004?
Your answer should be compact. 1.26. What is the ratio of the Emissions(in percent) in Slovak Republic in 2001 to that in 2004?
Ensure brevity in your answer.  0.91. What is the ratio of the Emissions(in percent) of Heavily indebted poor countries in 2002 to that in 2003?
Your answer should be compact. 1.02. What is the ratio of the Emissions(in percent) of Nigeria in 2002 to that in 2003?
Provide a succinct answer. 1.07. What is the ratio of the Emissions(in percent) of Slovak Republic in 2002 to that in 2003?
Provide a succinct answer. 1.08. What is the ratio of the Emissions(in percent) in Heavily indebted poor countries in 2002 to that in 2004?
Provide a short and direct response. 1.01. What is the ratio of the Emissions(in percent) in Chad in 2002 to that in 2004?
Provide a succinct answer. 1. What is the ratio of the Emissions(in percent) in Nigeria in 2002 to that in 2004?
Your answer should be compact. 1.2. What is the ratio of the Emissions(in percent) in Slovak Republic in 2002 to that in 2004?
Your answer should be very brief. 1.06. What is the ratio of the Emissions(in percent) of Nigeria in 2003 to that in 2004?
Provide a succinct answer. 1.12. What is the ratio of the Emissions(in percent) of Slovak Republic in 2003 to that in 2004?
Offer a very short reply. 0.98. What is the difference between the highest and the second highest Emissions(in percent) in Heavily indebted poor countries?
Provide a short and direct response. 0.84. What is the difference between the highest and the second highest Emissions(in percent) in Nigeria?
Offer a terse response. 0.02. What is the difference between the highest and the second highest Emissions(in percent) of Slovak Republic?
Offer a terse response. 1.18. What is the difference between the highest and the lowest Emissions(in percent) of Heavily indebted poor countries?
Keep it short and to the point. 4. What is the difference between the highest and the lowest Emissions(in percent) of Nigeria?
Your answer should be very brief. 38.39. What is the difference between the highest and the lowest Emissions(in percent) in Slovak Republic?
Give a very brief answer. 6.47. 